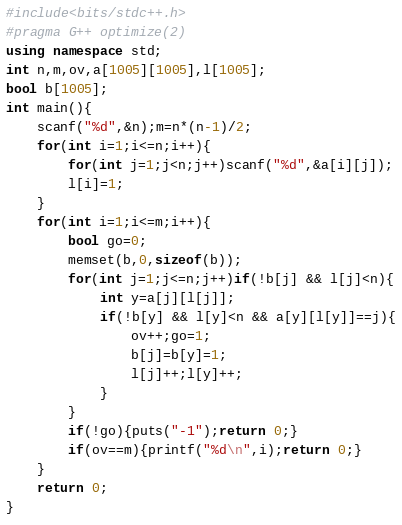<code> <loc_0><loc_0><loc_500><loc_500><_C++_>#include<bits/stdc++.h>
#pragma G++ optimize(2)
using namespace std;
int n,m,ov,a[1005][1005],l[1005];
bool b[1005];
int main(){
	scanf("%d",&n);m=n*(n-1)/2;
	for(int i=1;i<=n;i++){
		for(int j=1;j<n;j++)scanf("%d",&a[i][j]);
		l[i]=1;
	}
	for(int i=1;i<=m;i++){
		bool go=0;
		memset(b,0,sizeof(b));
		for(int j=1;j<=n;j++)if(!b[j] && l[j]<n){
			int y=a[j][l[j]];
			if(!b[y] && l[y]<n && a[y][l[y]]==j){
				ov++;go=1;
				b[j]=b[y]=1;
				l[j]++;l[y]++;
			}
		}
		if(!go){puts("-1");return 0;}
		if(ov==m){printf("%d\n",i);return 0;}
	}
	return 0;
}</code> 